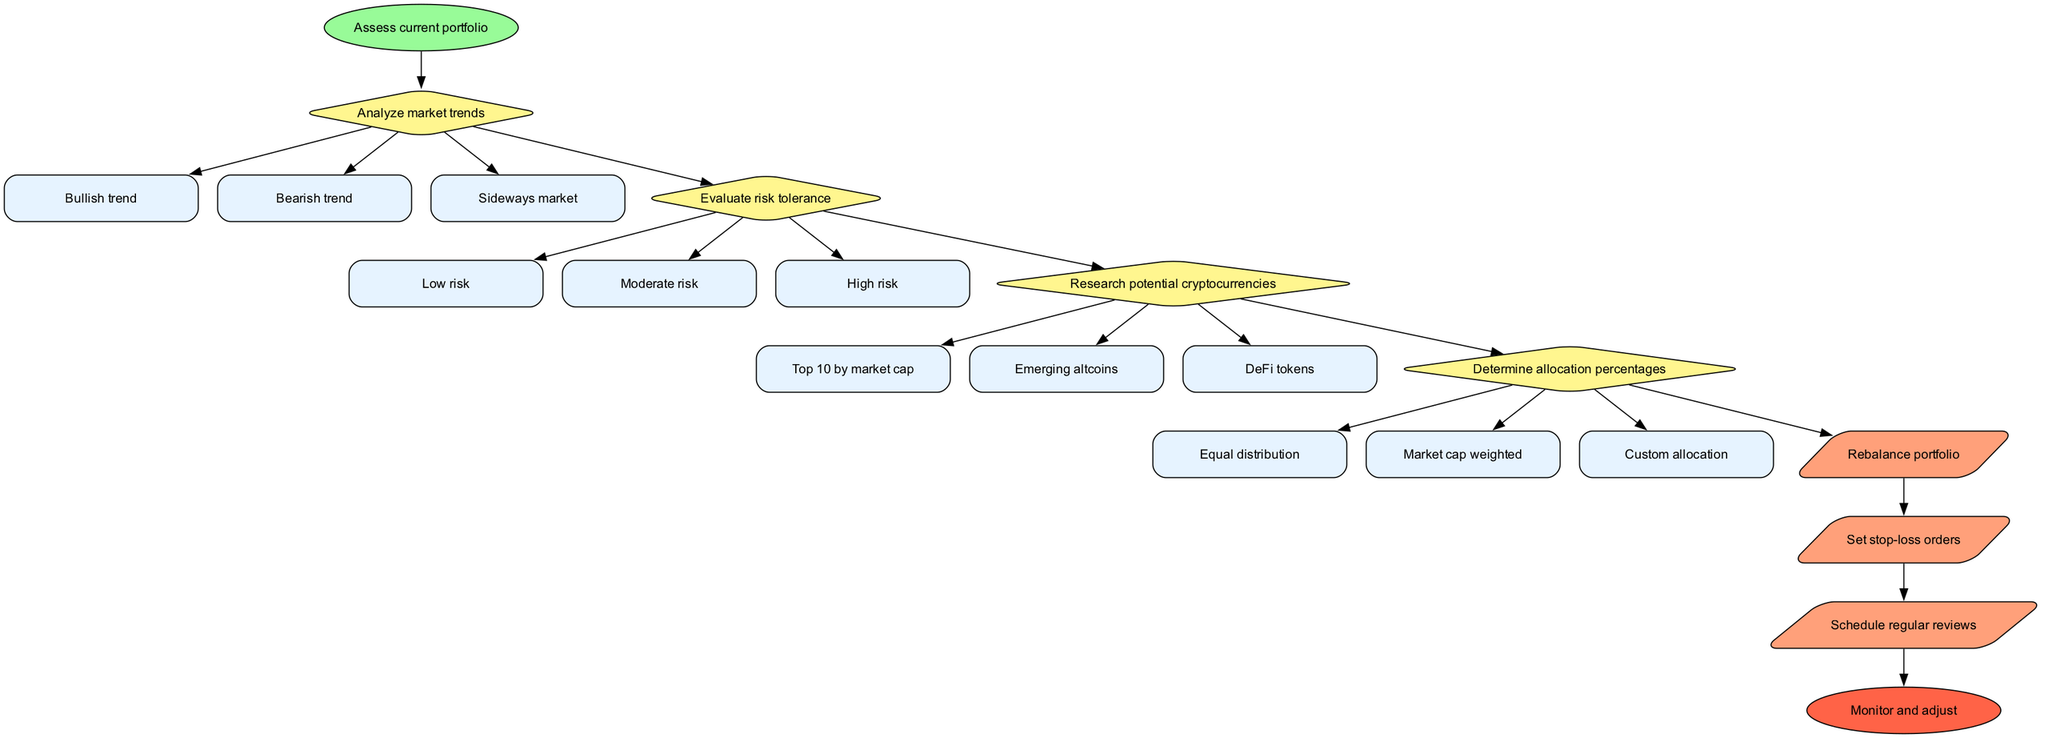What is the starting node of the flow chart? The starting node is clearly defined as "Assess current portfolio." This is the initial step in the decision-making process depicted in the diagram.
Answer: Assess current portfolio How many decision nodes are present in the diagram? The diagram contains four decision nodes: "Analyze market trends," "Evaluate risk tolerance," "Research potential cryptocurrencies," and "Determine allocation percentages." This totals to four decision nodes.
Answer: 4 What are the options under the node "Analyze market trends"? The options listed under "Analyze market trends" are "Bullish trend," "Bearish trend," and "Sideways market," which are key market conditions to be assessed.
Answer: Bullish trend, Bearish trend, Sideways market Which action follows the last decision node? The last decision node is "Determine allocation percentages," followed by the action "Rebalance portfolio." This signifies that after determining allocations, rebalancing the portfolio is the next step.
Answer: Rebalance portfolio If the risk tolerance is high, what could be a possible next action based on the decisions made? If the risk tolerance is high, the investor may choose options aligned with more aggressive investments. This can lead to rebalancing the portfolio or possibly setting stop-loss orders later in the process.
Answer: Rebalance portfolio What type of node is "Monitor and adjust"? "Monitor and adjust" is the end node of the flow chart, indicated by its oval shape and the red color that signifies the conclusion of the decision-making process.
Answer: End node What are the three risk tolerance options available? The options for risk tolerance include "Low risk," "Moderate risk," and "High risk." These options help investors define their comfort with market volatility when making decisions.
Answer: Low risk, Moderate risk, High risk How does the diagram structure the decision-making process? The diagram structures the decision-making process hierarchically, beginning with a starting point, followed by decisions that lead to actions, culminating in an end node. Each decision informs the next steps in the process.
Answer: Hierarchically structured What is the purpose of setting stop-loss orders? Setting stop-loss orders is a risk management action that helps protect investments by automatically selling assets once they reach a certain price, preventing larger losses.
Answer: Protect investments 